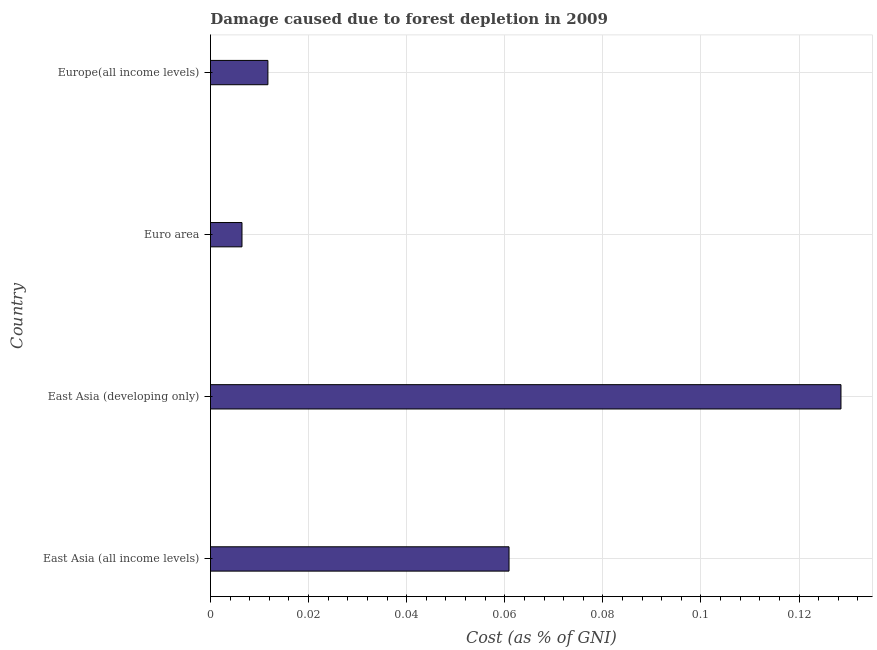Does the graph contain any zero values?
Provide a succinct answer. No. Does the graph contain grids?
Your answer should be compact. Yes. What is the title of the graph?
Your answer should be compact. Damage caused due to forest depletion in 2009. What is the label or title of the X-axis?
Your answer should be very brief. Cost (as % of GNI). What is the label or title of the Y-axis?
Your response must be concise. Country. What is the damage caused due to forest depletion in Euro area?
Give a very brief answer. 0.01. Across all countries, what is the maximum damage caused due to forest depletion?
Provide a succinct answer. 0.13. Across all countries, what is the minimum damage caused due to forest depletion?
Make the answer very short. 0.01. In which country was the damage caused due to forest depletion maximum?
Your answer should be very brief. East Asia (developing only). In which country was the damage caused due to forest depletion minimum?
Give a very brief answer. Euro area. What is the sum of the damage caused due to forest depletion?
Provide a succinct answer. 0.21. What is the difference between the damage caused due to forest depletion in East Asia (developing only) and Europe(all income levels)?
Your answer should be compact. 0.12. What is the average damage caused due to forest depletion per country?
Your answer should be compact. 0.05. What is the median damage caused due to forest depletion?
Offer a very short reply. 0.04. What is the ratio of the damage caused due to forest depletion in East Asia (all income levels) to that in Euro area?
Ensure brevity in your answer.  9.47. Is the damage caused due to forest depletion in East Asia (all income levels) less than that in Euro area?
Your response must be concise. No. What is the difference between the highest and the second highest damage caused due to forest depletion?
Keep it short and to the point. 0.07. What is the difference between the highest and the lowest damage caused due to forest depletion?
Your answer should be very brief. 0.12. How many bars are there?
Keep it short and to the point. 4. Are all the bars in the graph horizontal?
Ensure brevity in your answer.  Yes. How many countries are there in the graph?
Provide a short and direct response. 4. What is the Cost (as % of GNI) of East Asia (all income levels)?
Ensure brevity in your answer.  0.06. What is the Cost (as % of GNI) of East Asia (developing only)?
Your answer should be compact. 0.13. What is the Cost (as % of GNI) of Euro area?
Your response must be concise. 0.01. What is the Cost (as % of GNI) of Europe(all income levels)?
Offer a very short reply. 0.01. What is the difference between the Cost (as % of GNI) in East Asia (all income levels) and East Asia (developing only)?
Keep it short and to the point. -0.07. What is the difference between the Cost (as % of GNI) in East Asia (all income levels) and Euro area?
Your answer should be very brief. 0.05. What is the difference between the Cost (as % of GNI) in East Asia (all income levels) and Europe(all income levels)?
Ensure brevity in your answer.  0.05. What is the difference between the Cost (as % of GNI) in East Asia (developing only) and Euro area?
Your answer should be very brief. 0.12. What is the difference between the Cost (as % of GNI) in East Asia (developing only) and Europe(all income levels)?
Ensure brevity in your answer.  0.12. What is the difference between the Cost (as % of GNI) in Euro area and Europe(all income levels)?
Offer a very short reply. -0.01. What is the ratio of the Cost (as % of GNI) in East Asia (all income levels) to that in East Asia (developing only)?
Offer a terse response. 0.47. What is the ratio of the Cost (as % of GNI) in East Asia (all income levels) to that in Euro area?
Your answer should be very brief. 9.47. What is the ratio of the Cost (as % of GNI) in East Asia (all income levels) to that in Europe(all income levels)?
Provide a short and direct response. 5.2. What is the ratio of the Cost (as % of GNI) in East Asia (developing only) to that in Euro area?
Ensure brevity in your answer.  20.01. What is the ratio of the Cost (as % of GNI) in East Asia (developing only) to that in Europe(all income levels)?
Provide a succinct answer. 10.98. What is the ratio of the Cost (as % of GNI) in Euro area to that in Europe(all income levels)?
Offer a terse response. 0.55. 